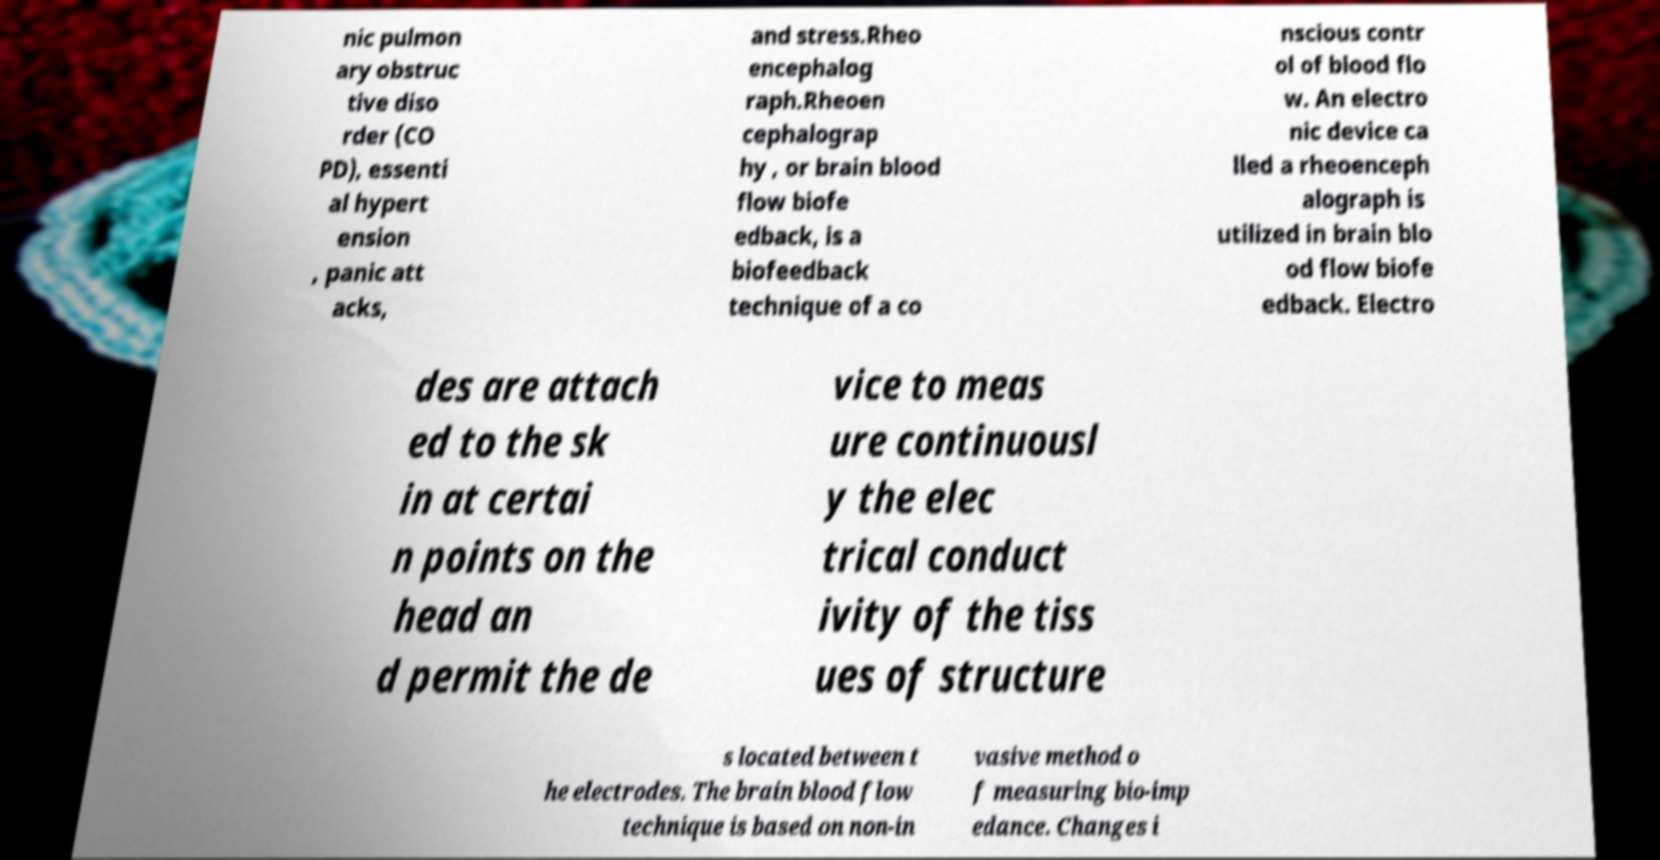For documentation purposes, I need the text within this image transcribed. Could you provide that? nic pulmon ary obstruc tive diso rder (CO PD), essenti al hypert ension , panic att acks, and stress.Rheo encephalog raph.Rheoen cephalograp hy , or brain blood flow biofe edback, is a biofeedback technique of a co nscious contr ol of blood flo w. An electro nic device ca lled a rheoenceph alograph is utilized in brain blo od flow biofe edback. Electro des are attach ed to the sk in at certai n points on the head an d permit the de vice to meas ure continuousl y the elec trical conduct ivity of the tiss ues of structure s located between t he electrodes. The brain blood flow technique is based on non-in vasive method o f measuring bio-imp edance. Changes i 